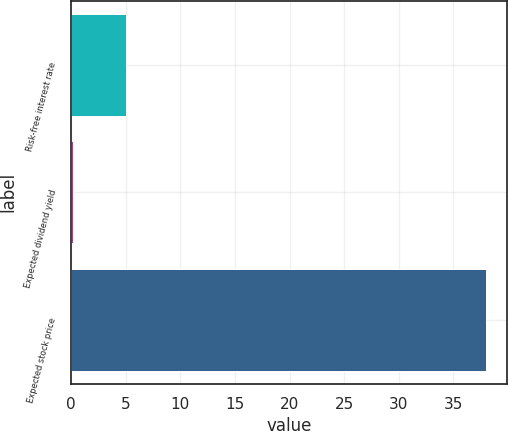<chart> <loc_0><loc_0><loc_500><loc_500><bar_chart><fcel>Risk-free interest rate<fcel>Expected dividend yield<fcel>Expected stock price<nl><fcel>4.99<fcel>0.15<fcel>38<nl></chart> 